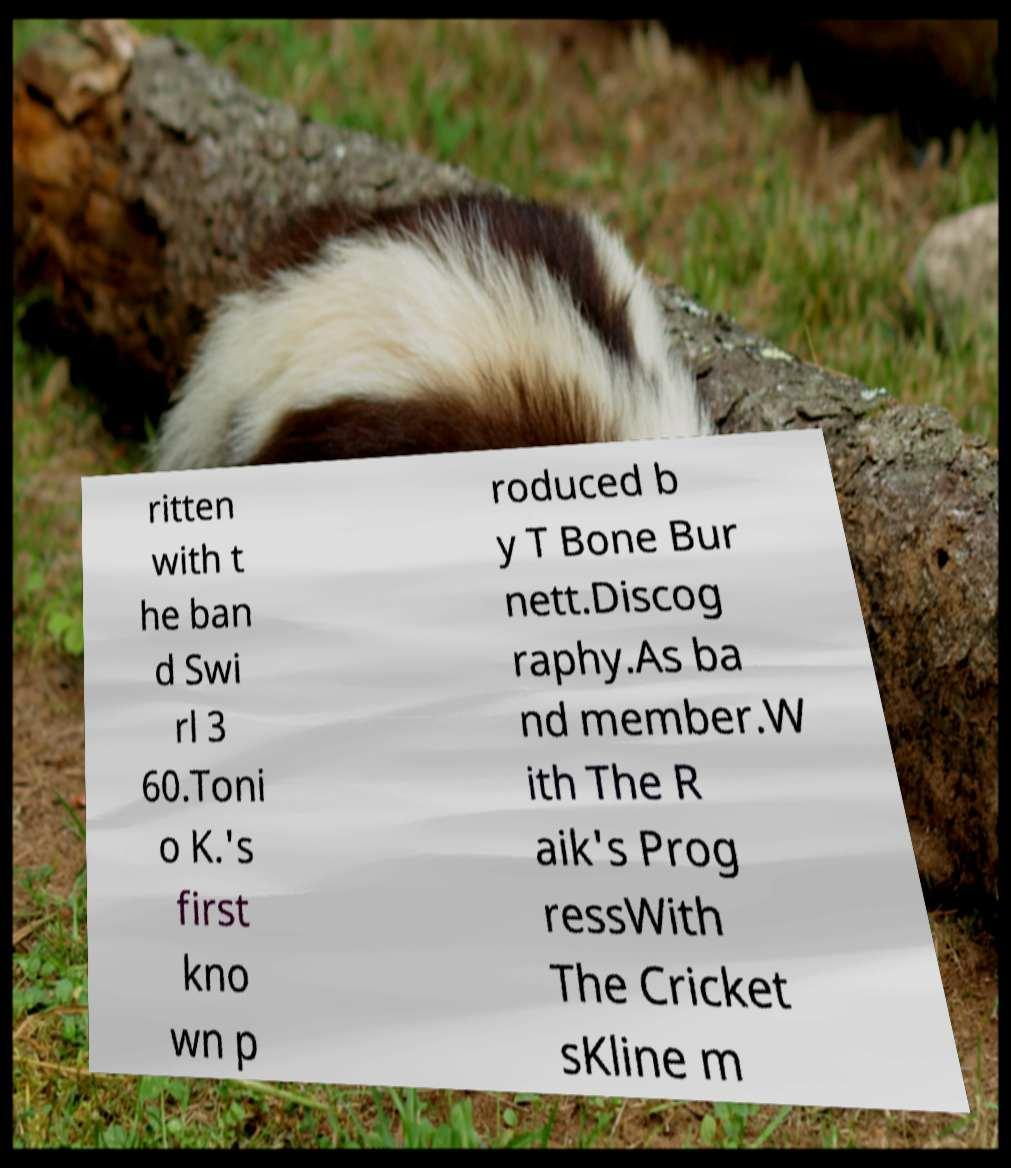For documentation purposes, I need the text within this image transcribed. Could you provide that? ritten with t he ban d Swi rl 3 60.Toni o K.'s first kno wn p roduced b y T Bone Bur nett.Discog raphy.As ba nd member.W ith The R aik's Prog ressWith The Cricket sKline m 